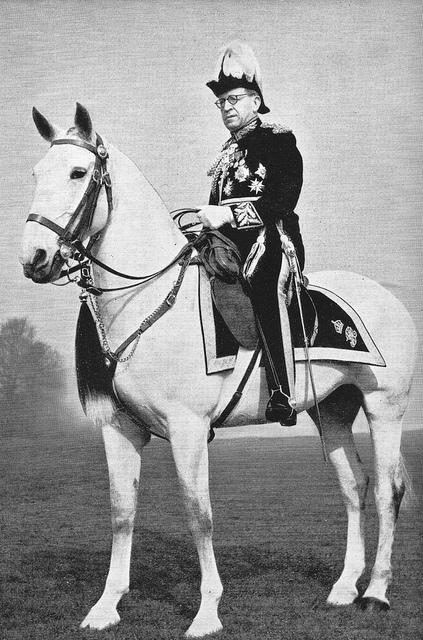What did this man serve in? military 